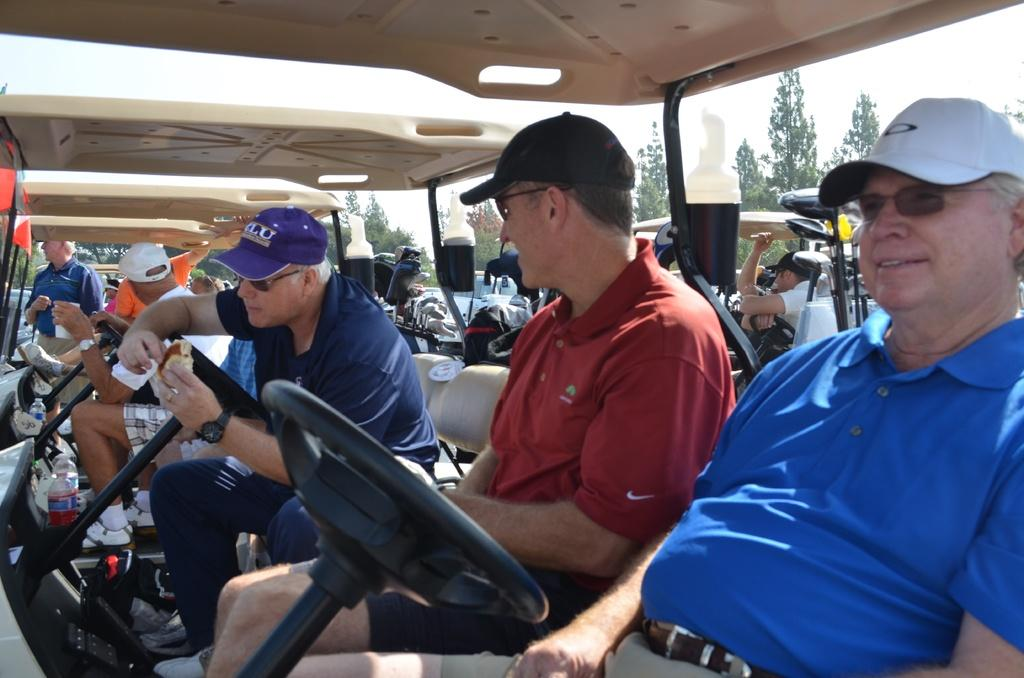What can be seen in large numbers in the image? There are many vehicles in the image. Who or what else is present in the image besides the vehicles? There are people in the image. What type of natural environment can be seen in the background of the image? There are trees in the background of the image. What is visible in the sky in the image? The sky is visible in the background of the image. Can you see any arches in the image? There is no mention of an arch in the provided facts, and therefore it cannot be determined if one is present in the image. 